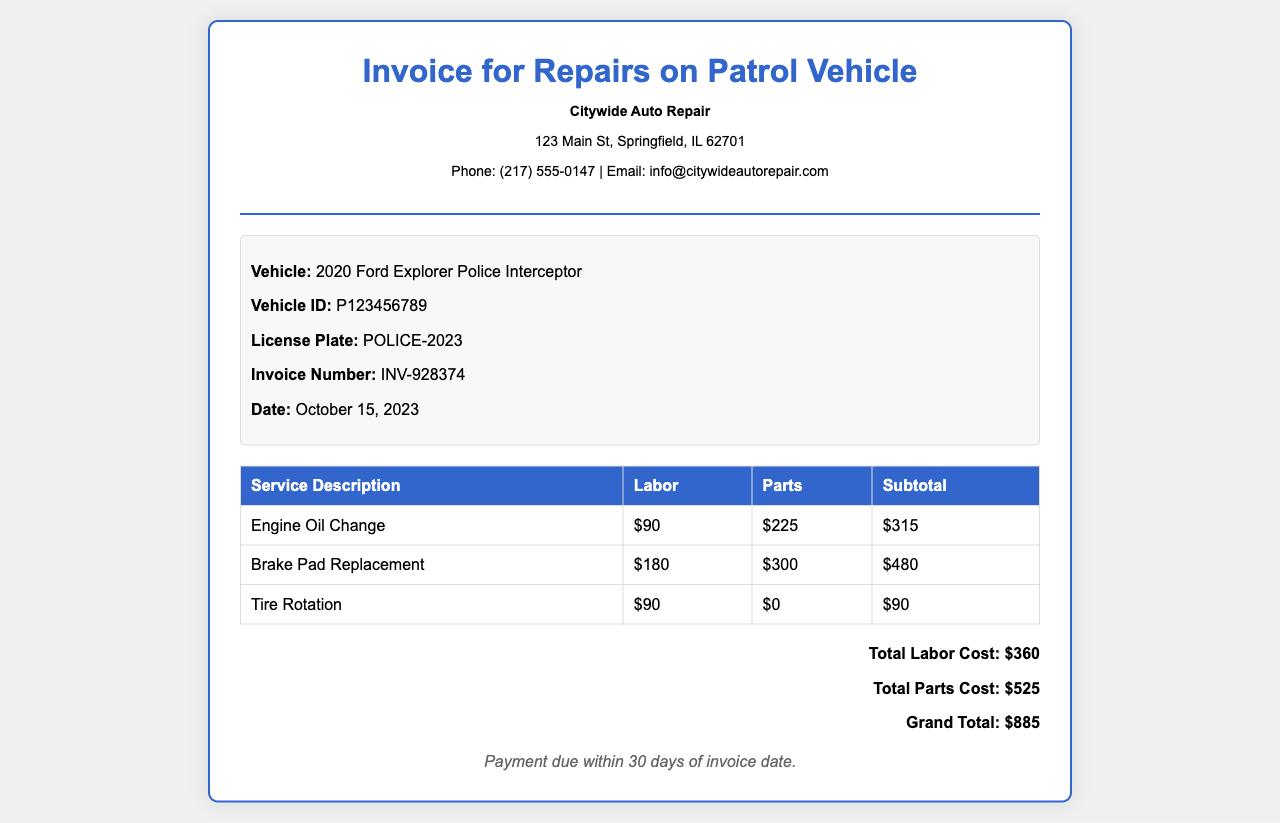What is the invoice number? The invoice number is specifically listed in the document under the vehicle information section, which is INV-928374.
Answer: INV-928374 What is the date of the invoice? The date is provided in the vehicle information section as the date the invoice was issued, which is October 15, 2023.
Answer: October 15, 2023 How much is the total labor cost? The total labor cost is calculated as the sum of all labor charges listed in the service table, which is $90 + $180 + $90 = $360.
Answer: $360 What is the grand total for the repairs? The grand total is calculated and presented in the totals section of the document, which sums all costs to $885.
Answer: $885 How many services are listed in the invoice? The invoice contains three line items for services provided, detailed in the service description table.
Answer: Three What item has the highest parts cost? The item with the highest parts cost can be deduced by comparing the parts costs in the service description table, which is Brake Pad Replacement at $300.
Answer: Brake Pad Replacement What is the payment term mentioned in the invoice? The payment term is explicitly stated in the document, which indicates payments are due within 30 days of the invoice date.
Answer: 30 days What vehicle is listed on the invoice? The vehicle information details that the repair invoice is for a 2020 Ford Explorer Police Interceptor.
Answer: 2020 Ford Explorer Police Interceptor What is the service description for the tire rotation? The service description for tire rotation is mentioned in the service table as Tire Rotation.
Answer: Tire Rotation 